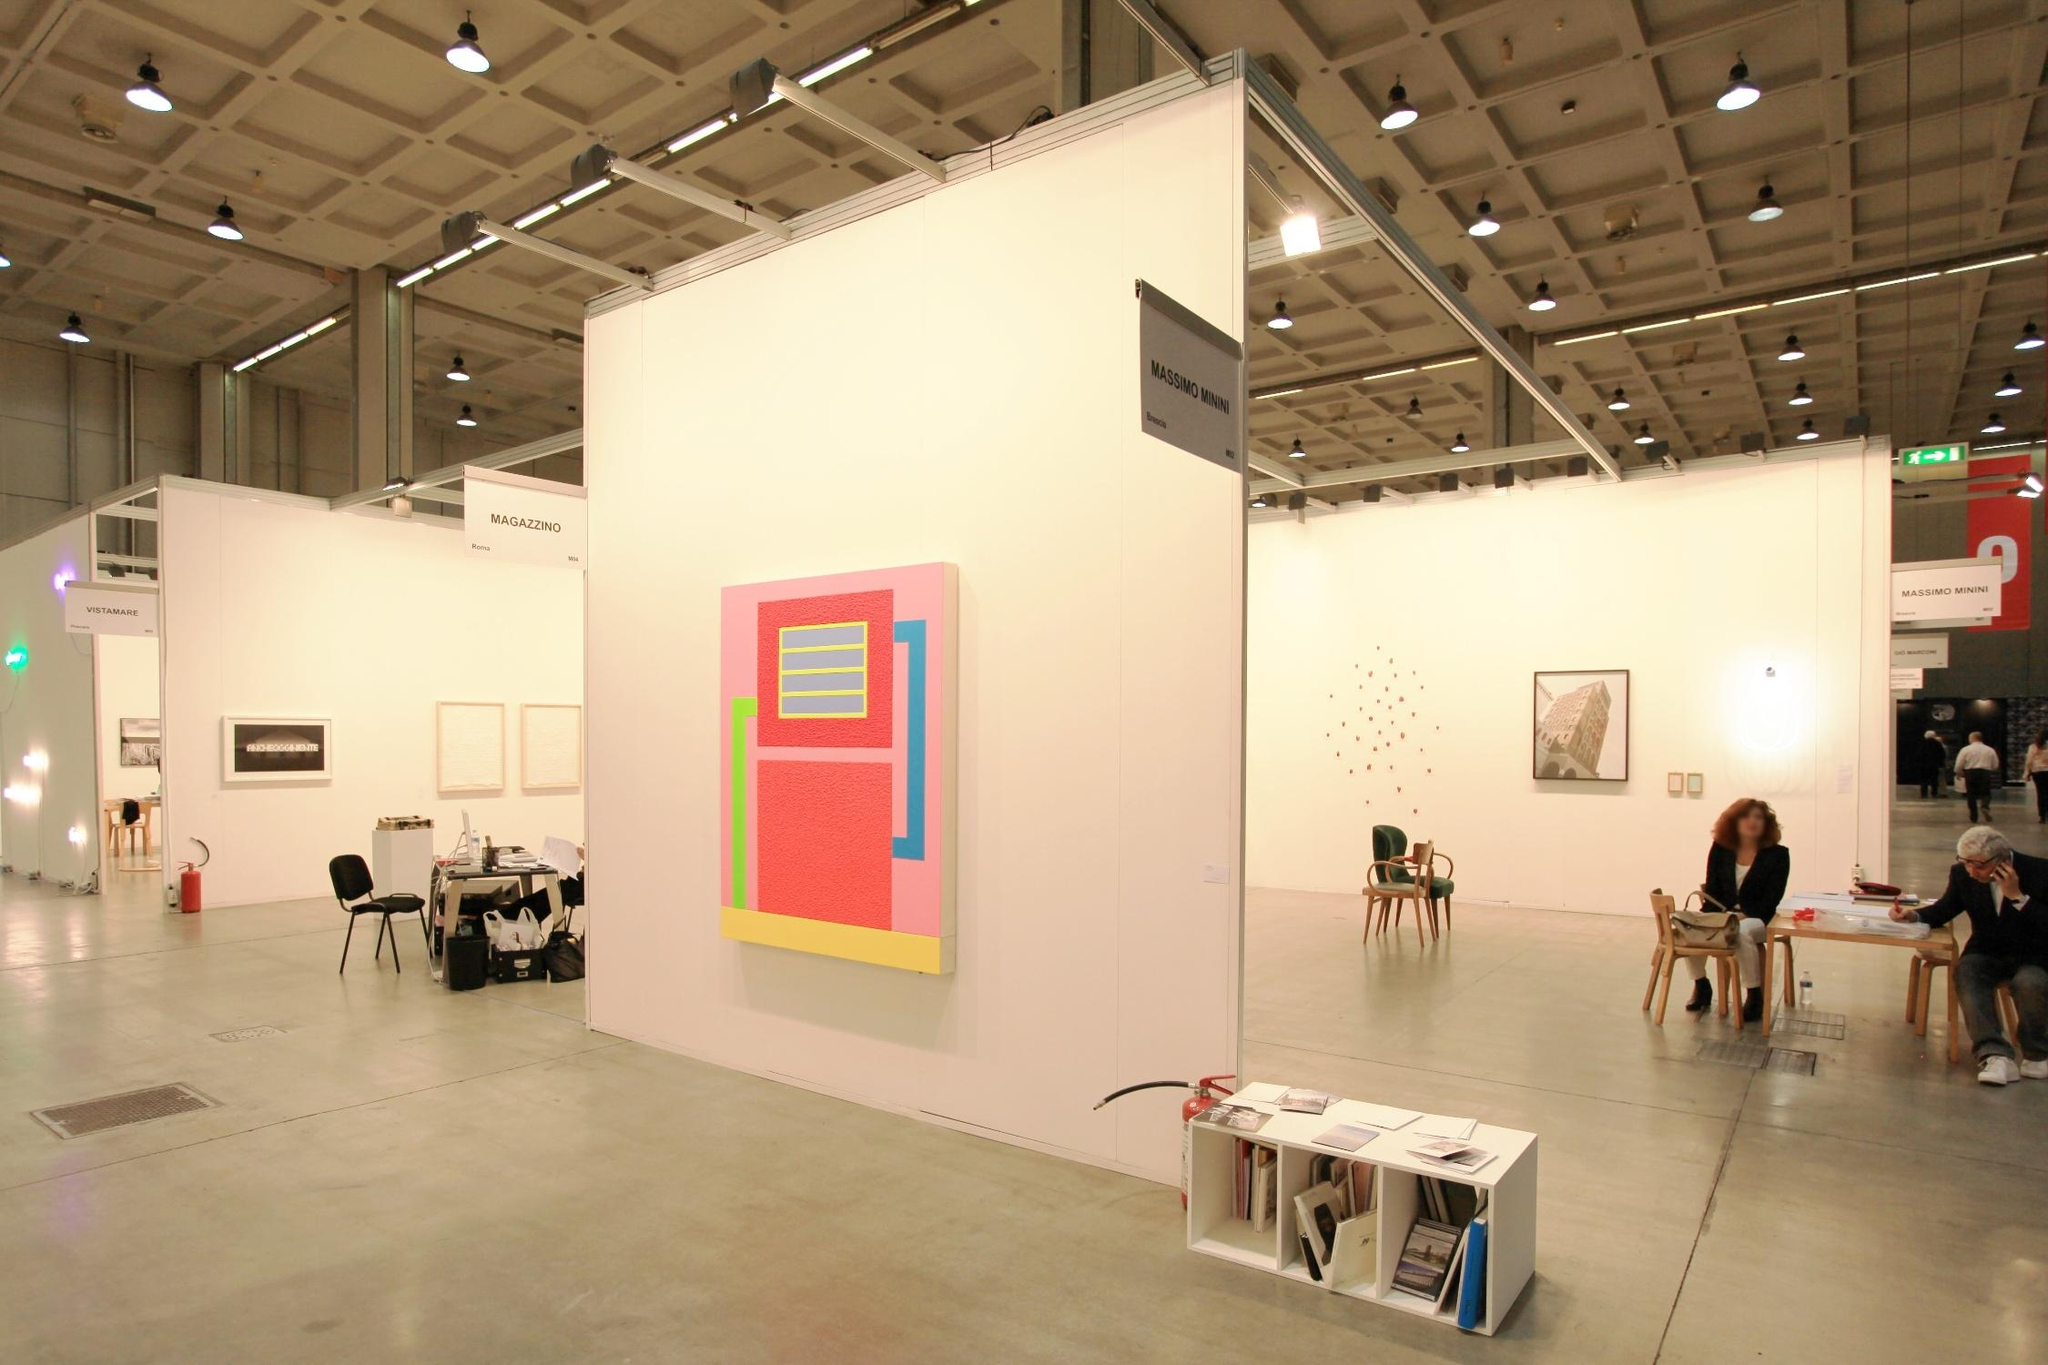Can you tell more about the other artworks visible in the background? Behind the main geometric painting, the gallery continues with several other artworks. To the right, there's a collection of small red dot patterns on a white canvas, which might explore concepts like repetition or minimalism. Farther in the background, there are framed pieces that appear to be black and white photographs or monochrome prints, which could contrast with the vibrant abstract works, offering a more subdued or reflective visual experience. 